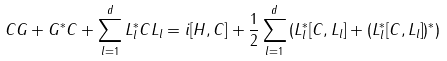<formula> <loc_0><loc_0><loc_500><loc_500>C G + G ^ { * } C + \sum _ { l = 1 } ^ { d } L _ { l } ^ { * } C L _ { l } = i [ H , C ] + \frac { 1 } { 2 } \sum _ { l = 1 } ^ { d } \left ( L _ { l } ^ { * } [ C , L _ { l } ] + ( L _ { l } ^ { * } [ C , L _ { l } ] ) ^ { * } \right )</formula> 